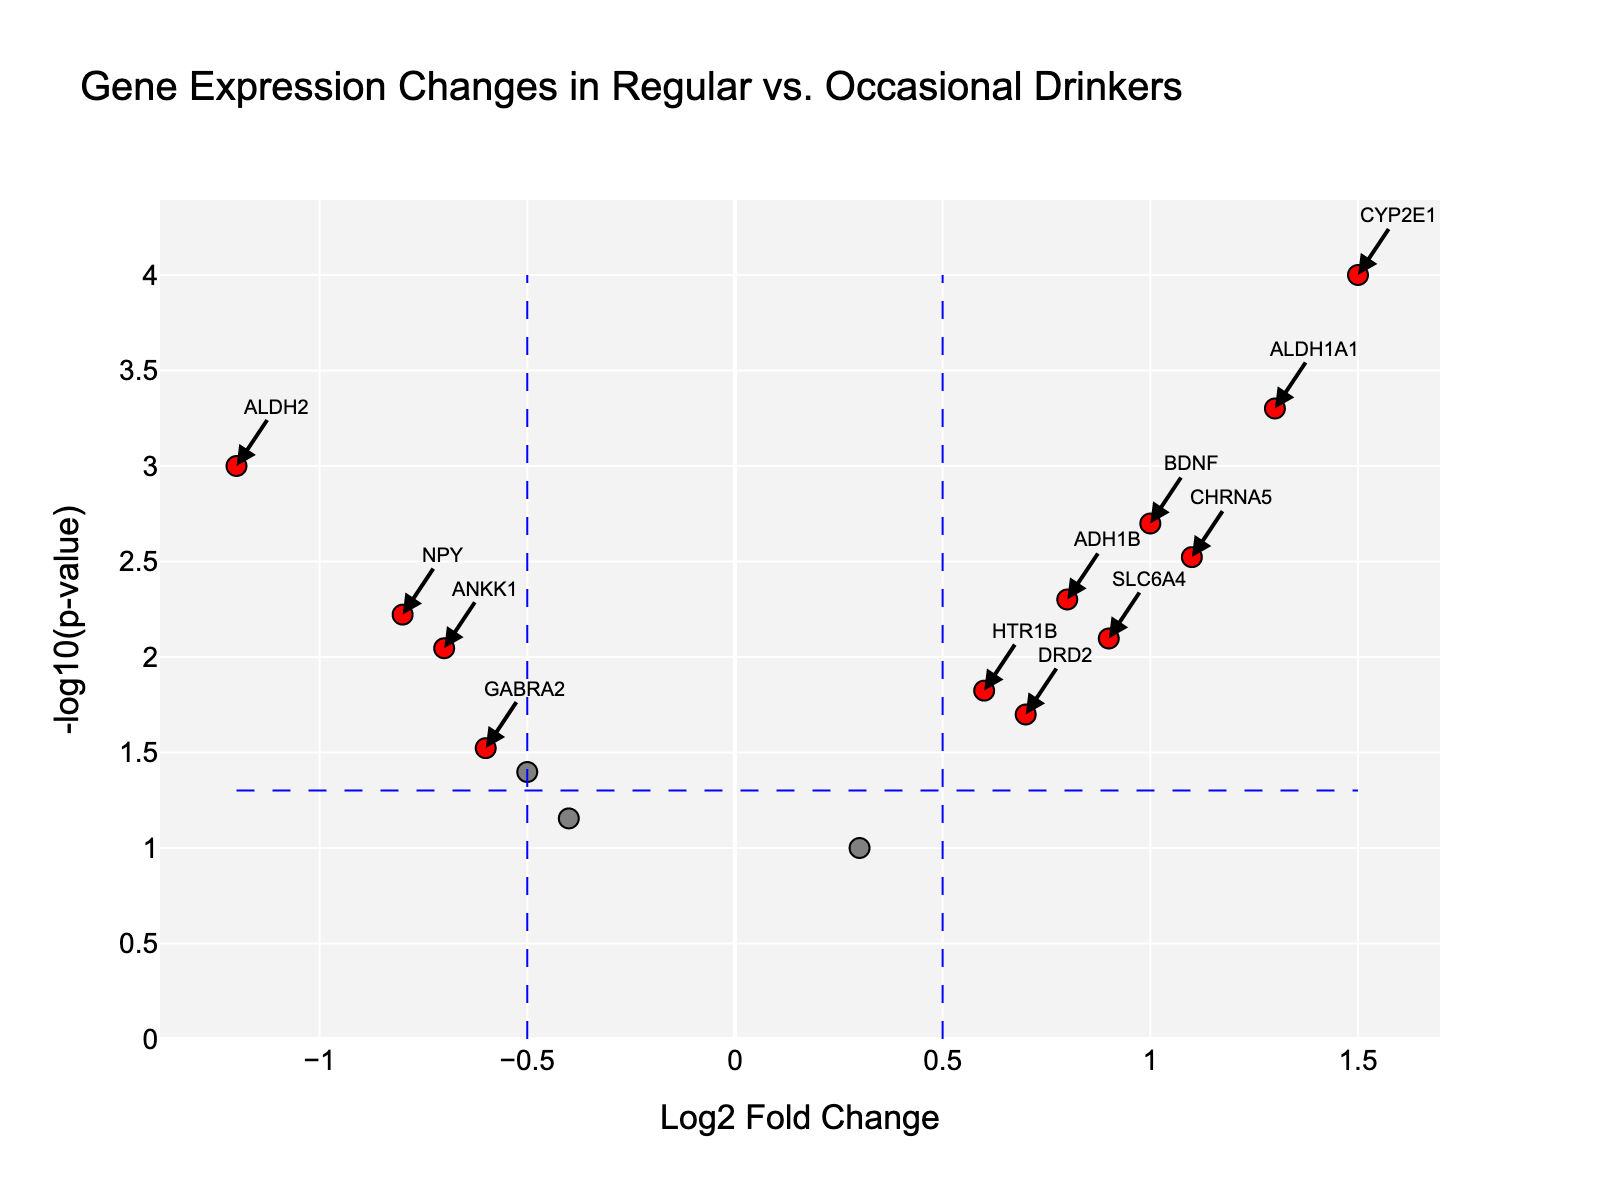What is the title of the figure? The title is typically displayed at the top of the figure. It provides an overview of the contents and purpose of the figure.
Answer: Gene Expression Changes in Regular vs. Occasional Drinkers How many genes are significantly different in expression between regular and occasional drinkers? Significant genes are marked in red. By counting the red dots on the plot, we can determine the number of significantly different genes.
Answer: 6 Which gene has the highest Log2 Fold Change? The highest Log2 Fold Change is represented by the highest point on the x-axis. Identify the gene corresponding to this point.
Answer: CYP2E1 Which gene has the smallest p-value? The smallest p-value corresponds to the highest point on the y-axis. Identify the gene corresponding to this point.
Answer: CYP2E1 What is the Log2 Fold Change and p-value for the ALDH2 gene? Find the point labeled "ALDH2" on the plot. The Log2 Fold Change is the x-coordinate, and the p-value is calculated by 10^(-y-coordinate).
Answer: Log2 Fold Change: -1.2, p-value: 0.001 Are there more genes with a positive or negative Log2 Fold Change? Count the number of points to the right of the y-axis (positive Log2 Fold Change) and compare it to the number of points to the left (negative Log2 Fold Change).
Answer: Positive Which gene is closest to the threshold lines for Log2 Fold Change and p-value? Identify the gene closest to x = ±0.5 and y = -log10(0.05). Hover over the points near these lines to find the closest gene.
Answer: DRD2 How many genes have a Log2 Fold Change greater than 1? Count the number of points to the right of the line at Log2 Fold Change = 1.
Answer: 3 Which genes are upregulated (positive Log2 Fold Change) and significant (p-value < 0.05)? Identify the points in the top right quadrant (positive x-values and red color). List the corresponding genes.
Answer: ADH1B, CYP2E1, SLC6A4, CHRNA5, BDNF, ALDH1A1 Which gene has the highest negative Log2 Fold Change? The highest negative Log2 Fold Change is represented by the lowest point on the x-axis. Identify the gene corresponding to this point.
Answer: ALDH2 